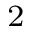Convert formula to latex. <formula><loc_0><loc_0><loc_500><loc_500>_ { 2 }</formula> 